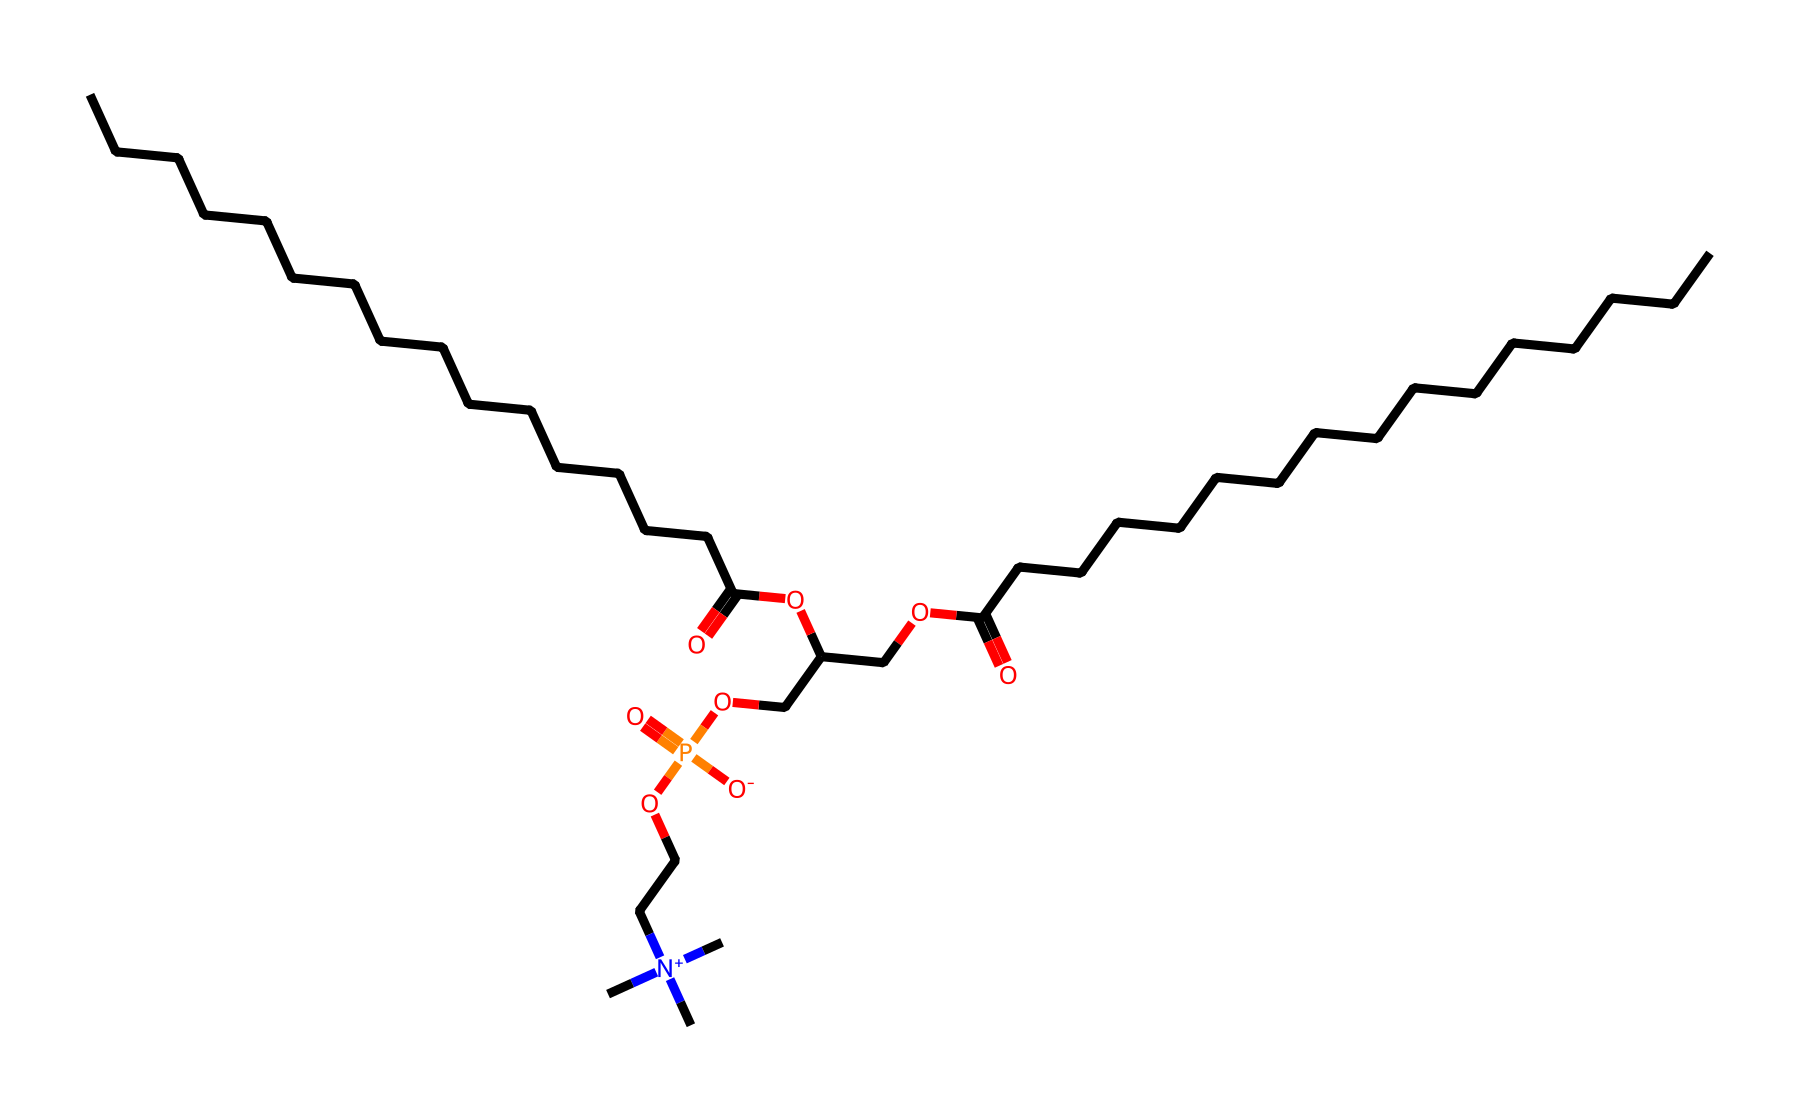What is the common name of this chemical? The SMILES structure corresponds to lecithin, which is a phospholipid and a natural surfactant found in various food sources.
Answer: lecithin How many carbon atoms are present in this chemical? By counting the 'C' in the SMILES representation, there are 22 carbon atoms in total.
Answer: 22 What functional groups are present in this molecule? The molecule contains ester groups (indicated by 'OC(=O)') and a phosphate group (denoted by 'P(=O)([O-])') as key functional components.
Answer: ester and phosphate Which part of this molecule contributes to its surfactant properties? The hydrophilic phosphate head (the part connected to the 'P' atom) and the hydrophobic long hydrocarbon tails contribute to the surfactant properties.
Answer: hydrophilic phosphate head and hydrophobic tails What is the significance of the positively charged nitrogen in this structure? The positively charged nitrogen atom, found in the quaternary ammonium group, enhances water solubility and surfactant activity by promoting interactions with polar solvents.
Answer: enhances water solubility How does the arrangement of hydrophobic and hydrophilic parts affect its functionality as a surfactant? The amphiphilic nature of lecithin, with distinct hydrophobic tails and a hydrophilic head, allows it to reduce surface tension and stabilize emulsions, making it effective in emulsifying agents.
Answer: amphiphilic nature 